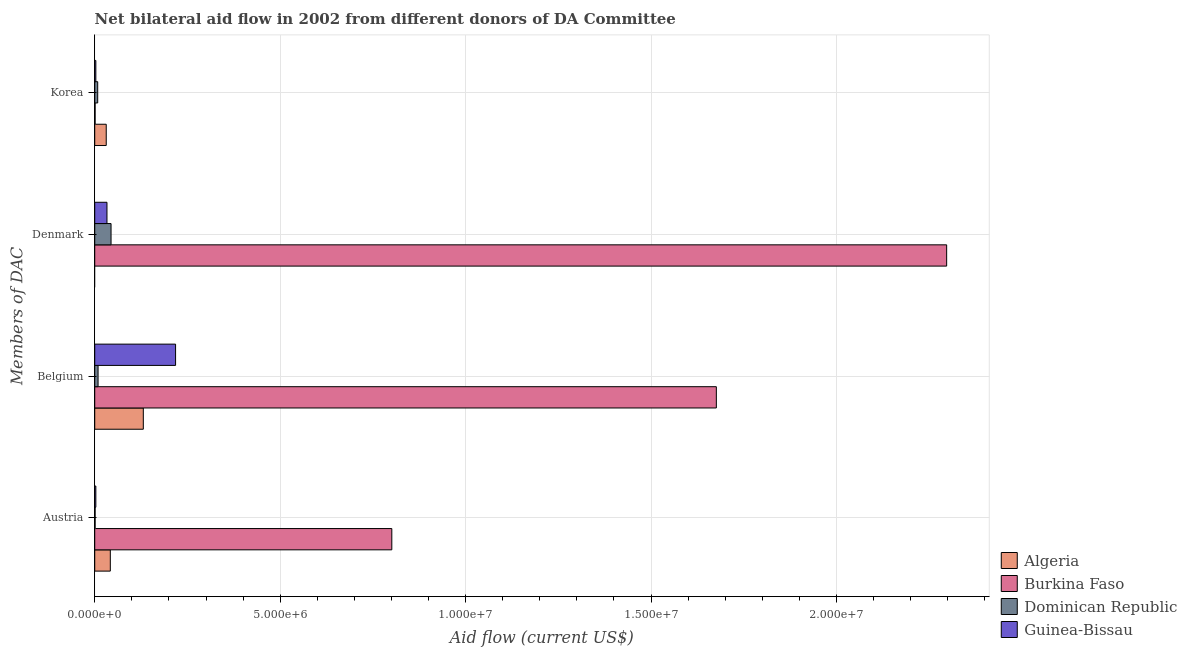How many different coloured bars are there?
Keep it short and to the point. 4. Are the number of bars per tick equal to the number of legend labels?
Ensure brevity in your answer.  No. Are the number of bars on each tick of the Y-axis equal?
Offer a terse response. No. How many bars are there on the 2nd tick from the top?
Make the answer very short. 3. How many bars are there on the 1st tick from the bottom?
Offer a very short reply. 4. What is the label of the 2nd group of bars from the top?
Give a very brief answer. Denmark. What is the amount of aid given by korea in Guinea-Bissau?
Offer a very short reply. 3.00e+04. Across all countries, what is the maximum amount of aid given by denmark?
Provide a succinct answer. 2.30e+07. Across all countries, what is the minimum amount of aid given by korea?
Your response must be concise. 10000. In which country was the amount of aid given by belgium maximum?
Provide a succinct answer. Burkina Faso. What is the total amount of aid given by korea in the graph?
Your answer should be very brief. 4.30e+05. What is the difference between the amount of aid given by belgium in Guinea-Bissau and that in Algeria?
Your answer should be compact. 8.70e+05. What is the difference between the amount of aid given by denmark in Dominican Republic and the amount of aid given by belgium in Burkina Faso?
Your response must be concise. -1.63e+07. What is the average amount of aid given by korea per country?
Make the answer very short. 1.08e+05. What is the difference between the amount of aid given by korea and amount of aid given by denmark in Dominican Republic?
Your answer should be compact. -3.60e+05. What is the ratio of the amount of aid given by denmark in Dominican Republic to that in Burkina Faso?
Give a very brief answer. 0.02. Is the difference between the amount of aid given by belgium in Dominican Republic and Burkina Faso greater than the difference between the amount of aid given by korea in Dominican Republic and Burkina Faso?
Your answer should be compact. No. What is the difference between the highest and the second highest amount of aid given by belgium?
Give a very brief answer. 1.46e+07. What is the difference between the highest and the lowest amount of aid given by belgium?
Ensure brevity in your answer.  1.67e+07. Is it the case that in every country, the sum of the amount of aid given by denmark and amount of aid given by korea is greater than the sum of amount of aid given by austria and amount of aid given by belgium?
Provide a succinct answer. Yes. Is it the case that in every country, the sum of the amount of aid given by austria and amount of aid given by belgium is greater than the amount of aid given by denmark?
Provide a succinct answer. No. How many bars are there?
Make the answer very short. 15. Are all the bars in the graph horizontal?
Your response must be concise. Yes. How many countries are there in the graph?
Your answer should be compact. 4. Does the graph contain any zero values?
Offer a very short reply. Yes. How many legend labels are there?
Provide a succinct answer. 4. What is the title of the graph?
Provide a short and direct response. Net bilateral aid flow in 2002 from different donors of DA Committee. Does "Low income" appear as one of the legend labels in the graph?
Give a very brief answer. No. What is the label or title of the Y-axis?
Ensure brevity in your answer.  Members of DAC. What is the Aid flow (current US$) of Burkina Faso in Austria?
Your response must be concise. 8.01e+06. What is the Aid flow (current US$) of Dominican Republic in Austria?
Your response must be concise. 10000. What is the Aid flow (current US$) of Guinea-Bissau in Austria?
Ensure brevity in your answer.  3.00e+04. What is the Aid flow (current US$) of Algeria in Belgium?
Your answer should be compact. 1.31e+06. What is the Aid flow (current US$) in Burkina Faso in Belgium?
Ensure brevity in your answer.  1.68e+07. What is the Aid flow (current US$) in Dominican Republic in Belgium?
Offer a very short reply. 9.00e+04. What is the Aid flow (current US$) of Guinea-Bissau in Belgium?
Provide a succinct answer. 2.18e+06. What is the Aid flow (current US$) of Algeria in Denmark?
Offer a very short reply. 0. What is the Aid flow (current US$) of Burkina Faso in Denmark?
Ensure brevity in your answer.  2.30e+07. What is the Aid flow (current US$) of Dominican Republic in Denmark?
Keep it short and to the point. 4.40e+05. What is the Aid flow (current US$) of Guinea-Bissau in Denmark?
Make the answer very short. 3.30e+05. What is the Aid flow (current US$) in Burkina Faso in Korea?
Your response must be concise. 10000. What is the Aid flow (current US$) of Dominican Republic in Korea?
Your answer should be very brief. 8.00e+04. Across all Members of DAC, what is the maximum Aid flow (current US$) of Algeria?
Keep it short and to the point. 1.31e+06. Across all Members of DAC, what is the maximum Aid flow (current US$) of Burkina Faso?
Make the answer very short. 2.30e+07. Across all Members of DAC, what is the maximum Aid flow (current US$) in Guinea-Bissau?
Give a very brief answer. 2.18e+06. Across all Members of DAC, what is the minimum Aid flow (current US$) of Dominican Republic?
Give a very brief answer. 10000. Across all Members of DAC, what is the minimum Aid flow (current US$) of Guinea-Bissau?
Provide a short and direct response. 3.00e+04. What is the total Aid flow (current US$) of Algeria in the graph?
Ensure brevity in your answer.  2.04e+06. What is the total Aid flow (current US$) of Burkina Faso in the graph?
Your answer should be compact. 4.78e+07. What is the total Aid flow (current US$) of Dominican Republic in the graph?
Offer a terse response. 6.20e+05. What is the total Aid flow (current US$) in Guinea-Bissau in the graph?
Your answer should be compact. 2.57e+06. What is the difference between the Aid flow (current US$) of Algeria in Austria and that in Belgium?
Keep it short and to the point. -8.90e+05. What is the difference between the Aid flow (current US$) in Burkina Faso in Austria and that in Belgium?
Offer a terse response. -8.75e+06. What is the difference between the Aid flow (current US$) of Guinea-Bissau in Austria and that in Belgium?
Make the answer very short. -2.15e+06. What is the difference between the Aid flow (current US$) in Burkina Faso in Austria and that in Denmark?
Provide a succinct answer. -1.50e+07. What is the difference between the Aid flow (current US$) in Dominican Republic in Austria and that in Denmark?
Give a very brief answer. -4.30e+05. What is the difference between the Aid flow (current US$) in Guinea-Bissau in Austria and that in Denmark?
Offer a very short reply. -3.00e+05. What is the difference between the Aid flow (current US$) of Burkina Faso in Belgium and that in Denmark?
Give a very brief answer. -6.21e+06. What is the difference between the Aid flow (current US$) in Dominican Republic in Belgium and that in Denmark?
Offer a very short reply. -3.50e+05. What is the difference between the Aid flow (current US$) in Guinea-Bissau in Belgium and that in Denmark?
Ensure brevity in your answer.  1.85e+06. What is the difference between the Aid flow (current US$) of Algeria in Belgium and that in Korea?
Your answer should be compact. 1.00e+06. What is the difference between the Aid flow (current US$) of Burkina Faso in Belgium and that in Korea?
Offer a terse response. 1.68e+07. What is the difference between the Aid flow (current US$) in Guinea-Bissau in Belgium and that in Korea?
Make the answer very short. 2.15e+06. What is the difference between the Aid flow (current US$) in Burkina Faso in Denmark and that in Korea?
Make the answer very short. 2.30e+07. What is the difference between the Aid flow (current US$) in Dominican Republic in Denmark and that in Korea?
Provide a succinct answer. 3.60e+05. What is the difference between the Aid flow (current US$) in Algeria in Austria and the Aid flow (current US$) in Burkina Faso in Belgium?
Make the answer very short. -1.63e+07. What is the difference between the Aid flow (current US$) of Algeria in Austria and the Aid flow (current US$) of Dominican Republic in Belgium?
Make the answer very short. 3.30e+05. What is the difference between the Aid flow (current US$) of Algeria in Austria and the Aid flow (current US$) of Guinea-Bissau in Belgium?
Provide a succinct answer. -1.76e+06. What is the difference between the Aid flow (current US$) of Burkina Faso in Austria and the Aid flow (current US$) of Dominican Republic in Belgium?
Make the answer very short. 7.92e+06. What is the difference between the Aid flow (current US$) in Burkina Faso in Austria and the Aid flow (current US$) in Guinea-Bissau in Belgium?
Make the answer very short. 5.83e+06. What is the difference between the Aid flow (current US$) in Dominican Republic in Austria and the Aid flow (current US$) in Guinea-Bissau in Belgium?
Give a very brief answer. -2.17e+06. What is the difference between the Aid flow (current US$) of Algeria in Austria and the Aid flow (current US$) of Burkina Faso in Denmark?
Ensure brevity in your answer.  -2.26e+07. What is the difference between the Aid flow (current US$) of Algeria in Austria and the Aid flow (current US$) of Dominican Republic in Denmark?
Offer a very short reply. -2.00e+04. What is the difference between the Aid flow (current US$) of Algeria in Austria and the Aid flow (current US$) of Guinea-Bissau in Denmark?
Offer a very short reply. 9.00e+04. What is the difference between the Aid flow (current US$) of Burkina Faso in Austria and the Aid flow (current US$) of Dominican Republic in Denmark?
Ensure brevity in your answer.  7.57e+06. What is the difference between the Aid flow (current US$) of Burkina Faso in Austria and the Aid flow (current US$) of Guinea-Bissau in Denmark?
Provide a short and direct response. 7.68e+06. What is the difference between the Aid flow (current US$) of Dominican Republic in Austria and the Aid flow (current US$) of Guinea-Bissau in Denmark?
Provide a succinct answer. -3.20e+05. What is the difference between the Aid flow (current US$) in Algeria in Austria and the Aid flow (current US$) in Burkina Faso in Korea?
Provide a succinct answer. 4.10e+05. What is the difference between the Aid flow (current US$) in Burkina Faso in Austria and the Aid flow (current US$) in Dominican Republic in Korea?
Your answer should be very brief. 7.93e+06. What is the difference between the Aid flow (current US$) of Burkina Faso in Austria and the Aid flow (current US$) of Guinea-Bissau in Korea?
Make the answer very short. 7.98e+06. What is the difference between the Aid flow (current US$) of Dominican Republic in Austria and the Aid flow (current US$) of Guinea-Bissau in Korea?
Your answer should be very brief. -2.00e+04. What is the difference between the Aid flow (current US$) in Algeria in Belgium and the Aid flow (current US$) in Burkina Faso in Denmark?
Your response must be concise. -2.17e+07. What is the difference between the Aid flow (current US$) in Algeria in Belgium and the Aid flow (current US$) in Dominican Republic in Denmark?
Your response must be concise. 8.70e+05. What is the difference between the Aid flow (current US$) of Algeria in Belgium and the Aid flow (current US$) of Guinea-Bissau in Denmark?
Make the answer very short. 9.80e+05. What is the difference between the Aid flow (current US$) of Burkina Faso in Belgium and the Aid flow (current US$) of Dominican Republic in Denmark?
Offer a terse response. 1.63e+07. What is the difference between the Aid flow (current US$) in Burkina Faso in Belgium and the Aid flow (current US$) in Guinea-Bissau in Denmark?
Your answer should be very brief. 1.64e+07. What is the difference between the Aid flow (current US$) in Dominican Republic in Belgium and the Aid flow (current US$) in Guinea-Bissau in Denmark?
Make the answer very short. -2.40e+05. What is the difference between the Aid flow (current US$) of Algeria in Belgium and the Aid flow (current US$) of Burkina Faso in Korea?
Provide a short and direct response. 1.30e+06. What is the difference between the Aid flow (current US$) of Algeria in Belgium and the Aid flow (current US$) of Dominican Republic in Korea?
Offer a very short reply. 1.23e+06. What is the difference between the Aid flow (current US$) in Algeria in Belgium and the Aid flow (current US$) in Guinea-Bissau in Korea?
Make the answer very short. 1.28e+06. What is the difference between the Aid flow (current US$) of Burkina Faso in Belgium and the Aid flow (current US$) of Dominican Republic in Korea?
Give a very brief answer. 1.67e+07. What is the difference between the Aid flow (current US$) of Burkina Faso in Belgium and the Aid flow (current US$) of Guinea-Bissau in Korea?
Offer a very short reply. 1.67e+07. What is the difference between the Aid flow (current US$) in Burkina Faso in Denmark and the Aid flow (current US$) in Dominican Republic in Korea?
Provide a succinct answer. 2.29e+07. What is the difference between the Aid flow (current US$) in Burkina Faso in Denmark and the Aid flow (current US$) in Guinea-Bissau in Korea?
Provide a short and direct response. 2.29e+07. What is the average Aid flow (current US$) of Algeria per Members of DAC?
Provide a succinct answer. 5.10e+05. What is the average Aid flow (current US$) in Burkina Faso per Members of DAC?
Provide a short and direct response. 1.19e+07. What is the average Aid flow (current US$) in Dominican Republic per Members of DAC?
Offer a very short reply. 1.55e+05. What is the average Aid flow (current US$) in Guinea-Bissau per Members of DAC?
Provide a succinct answer. 6.42e+05. What is the difference between the Aid flow (current US$) in Algeria and Aid flow (current US$) in Burkina Faso in Austria?
Offer a terse response. -7.59e+06. What is the difference between the Aid flow (current US$) of Algeria and Aid flow (current US$) of Dominican Republic in Austria?
Your response must be concise. 4.10e+05. What is the difference between the Aid flow (current US$) of Algeria and Aid flow (current US$) of Guinea-Bissau in Austria?
Ensure brevity in your answer.  3.90e+05. What is the difference between the Aid flow (current US$) in Burkina Faso and Aid flow (current US$) in Dominican Republic in Austria?
Provide a succinct answer. 8.00e+06. What is the difference between the Aid flow (current US$) of Burkina Faso and Aid flow (current US$) of Guinea-Bissau in Austria?
Ensure brevity in your answer.  7.98e+06. What is the difference between the Aid flow (current US$) in Dominican Republic and Aid flow (current US$) in Guinea-Bissau in Austria?
Give a very brief answer. -2.00e+04. What is the difference between the Aid flow (current US$) of Algeria and Aid flow (current US$) of Burkina Faso in Belgium?
Give a very brief answer. -1.54e+07. What is the difference between the Aid flow (current US$) in Algeria and Aid flow (current US$) in Dominican Republic in Belgium?
Your answer should be compact. 1.22e+06. What is the difference between the Aid flow (current US$) in Algeria and Aid flow (current US$) in Guinea-Bissau in Belgium?
Offer a terse response. -8.70e+05. What is the difference between the Aid flow (current US$) of Burkina Faso and Aid flow (current US$) of Dominican Republic in Belgium?
Make the answer very short. 1.67e+07. What is the difference between the Aid flow (current US$) of Burkina Faso and Aid flow (current US$) of Guinea-Bissau in Belgium?
Your answer should be very brief. 1.46e+07. What is the difference between the Aid flow (current US$) in Dominican Republic and Aid flow (current US$) in Guinea-Bissau in Belgium?
Provide a short and direct response. -2.09e+06. What is the difference between the Aid flow (current US$) in Burkina Faso and Aid flow (current US$) in Dominican Republic in Denmark?
Keep it short and to the point. 2.25e+07. What is the difference between the Aid flow (current US$) in Burkina Faso and Aid flow (current US$) in Guinea-Bissau in Denmark?
Make the answer very short. 2.26e+07. What is the difference between the Aid flow (current US$) in Dominican Republic and Aid flow (current US$) in Guinea-Bissau in Denmark?
Provide a short and direct response. 1.10e+05. What is the difference between the Aid flow (current US$) in Algeria and Aid flow (current US$) in Dominican Republic in Korea?
Your answer should be compact. 2.30e+05. What is the difference between the Aid flow (current US$) in Burkina Faso and Aid flow (current US$) in Dominican Republic in Korea?
Your answer should be very brief. -7.00e+04. What is the difference between the Aid flow (current US$) of Burkina Faso and Aid flow (current US$) of Guinea-Bissau in Korea?
Offer a very short reply. -2.00e+04. What is the ratio of the Aid flow (current US$) of Algeria in Austria to that in Belgium?
Keep it short and to the point. 0.32. What is the ratio of the Aid flow (current US$) in Burkina Faso in Austria to that in Belgium?
Provide a succinct answer. 0.48. What is the ratio of the Aid flow (current US$) of Guinea-Bissau in Austria to that in Belgium?
Offer a terse response. 0.01. What is the ratio of the Aid flow (current US$) in Burkina Faso in Austria to that in Denmark?
Ensure brevity in your answer.  0.35. What is the ratio of the Aid flow (current US$) of Dominican Republic in Austria to that in Denmark?
Make the answer very short. 0.02. What is the ratio of the Aid flow (current US$) in Guinea-Bissau in Austria to that in Denmark?
Give a very brief answer. 0.09. What is the ratio of the Aid flow (current US$) of Algeria in Austria to that in Korea?
Offer a very short reply. 1.35. What is the ratio of the Aid flow (current US$) of Burkina Faso in Austria to that in Korea?
Ensure brevity in your answer.  801. What is the ratio of the Aid flow (current US$) in Burkina Faso in Belgium to that in Denmark?
Make the answer very short. 0.73. What is the ratio of the Aid flow (current US$) of Dominican Republic in Belgium to that in Denmark?
Your answer should be very brief. 0.2. What is the ratio of the Aid flow (current US$) in Guinea-Bissau in Belgium to that in Denmark?
Keep it short and to the point. 6.61. What is the ratio of the Aid flow (current US$) of Algeria in Belgium to that in Korea?
Your response must be concise. 4.23. What is the ratio of the Aid flow (current US$) in Burkina Faso in Belgium to that in Korea?
Ensure brevity in your answer.  1676. What is the ratio of the Aid flow (current US$) of Guinea-Bissau in Belgium to that in Korea?
Your answer should be compact. 72.67. What is the ratio of the Aid flow (current US$) in Burkina Faso in Denmark to that in Korea?
Provide a succinct answer. 2297. What is the ratio of the Aid flow (current US$) of Dominican Republic in Denmark to that in Korea?
Provide a succinct answer. 5.5. What is the difference between the highest and the second highest Aid flow (current US$) of Algeria?
Your answer should be compact. 8.90e+05. What is the difference between the highest and the second highest Aid flow (current US$) of Burkina Faso?
Ensure brevity in your answer.  6.21e+06. What is the difference between the highest and the second highest Aid flow (current US$) in Guinea-Bissau?
Give a very brief answer. 1.85e+06. What is the difference between the highest and the lowest Aid flow (current US$) in Algeria?
Ensure brevity in your answer.  1.31e+06. What is the difference between the highest and the lowest Aid flow (current US$) in Burkina Faso?
Make the answer very short. 2.30e+07. What is the difference between the highest and the lowest Aid flow (current US$) in Dominican Republic?
Provide a succinct answer. 4.30e+05. What is the difference between the highest and the lowest Aid flow (current US$) of Guinea-Bissau?
Ensure brevity in your answer.  2.15e+06. 